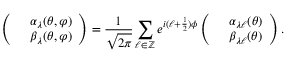<formula> <loc_0><loc_0><loc_500><loc_500>\left ( \begin{array} { c c } & { \alpha _ { \lambda } ( \theta , \varphi ) } \\ & { \beta _ { \lambda } ( \theta , \varphi ) } \end{array} \right ) = \frac { 1 } \sqrt { 2 \pi } } \sum _ { \ell \in \mathbb { Z } } e ^ { i ( \ell + \frac { 1 } { 2 } ) \phi } \left ( \begin{array} { c c } & { \alpha _ { \lambda \ell } ( \theta ) } \\ & { \beta _ { \lambda \ell } ( \theta ) } \end{array} \right ) .</formula> 